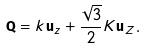<formula> <loc_0><loc_0><loc_500><loc_500>\mathbf Q = k \mathbf u _ { z } + \frac { \sqrt { 3 } } { 2 } K \mathbf u _ { Z } .</formula> 